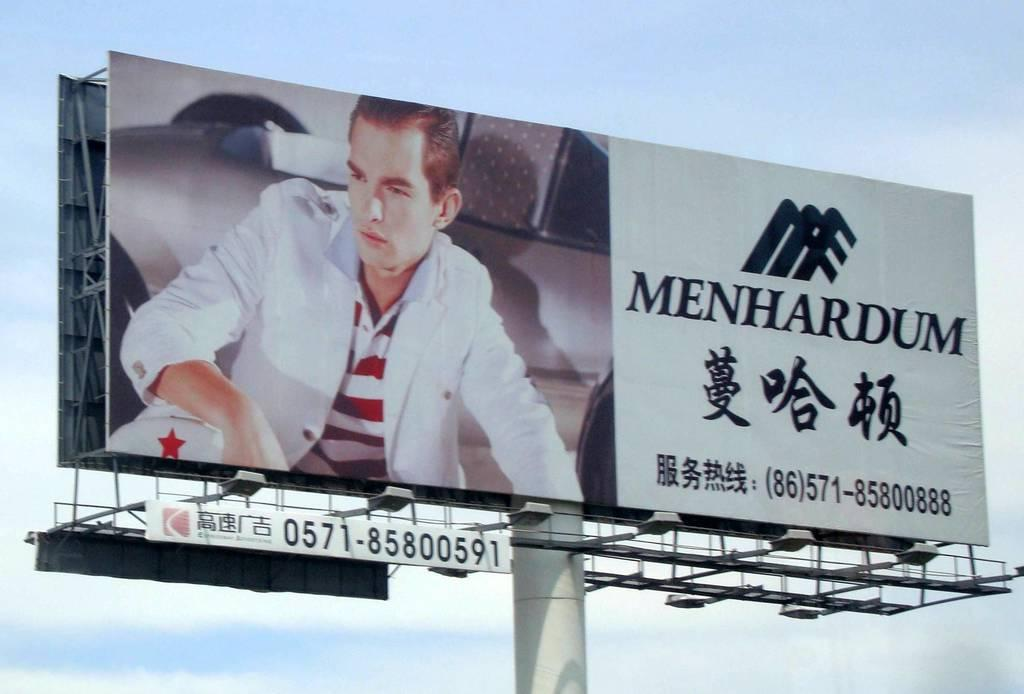<image>
Present a compact description of the photo's key features. A young man is dressed in a nice, casual suit, on a billboard for Menhardum. 